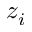<formula> <loc_0><loc_0><loc_500><loc_500>z _ { i }</formula> 